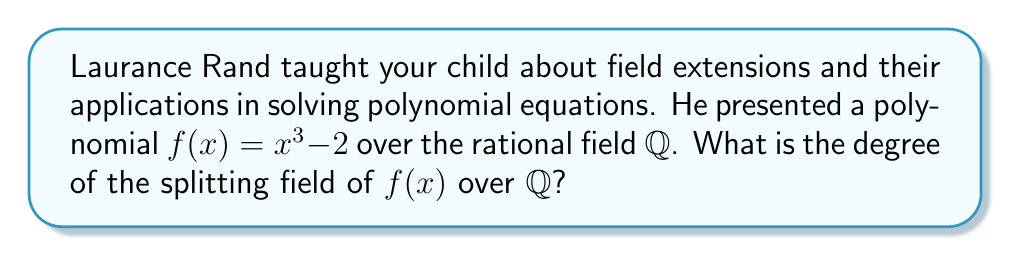Provide a solution to this math problem. Let's approach this step-by-step:

1) First, we need to find the roots of $f(x) = x^3 - 2$. 
   One real root is $\sqrt[3]{2}$. The other two roots are complex.

2) Let $\omega = e^{2\pi i/3} = -\frac{1}{2} + i\frac{\sqrt{3}}{2}$ be a primitive cube root of unity.
   Then the roots of $f(x)$ are:
   $$\sqrt[3]{2}, \omega\sqrt[3]{2}, \omega^2\sqrt[3]{2}$$

3) The splitting field of $f(x)$ over $\mathbb{Q}$ is:
   $$\mathbb{Q}(\sqrt[3]{2}, \omega)$$

4) To find the degree of this extension, we can use the tower law:
   $$[\mathbb{Q}(\sqrt[3]{2}, \omega) : \mathbb{Q}] = [\mathbb{Q}(\sqrt[3]{2}, \omega) : \mathbb{Q}(\sqrt[3]{2})][\mathbb{Q}(\sqrt[3]{2}) : \mathbb{Q}]$$

5) $[\mathbb{Q}(\sqrt[3]{2}) : \mathbb{Q}] = 3$ because $x^3 - 2$ is irreducible over $\mathbb{Q}$.

6) $[\mathbb{Q}(\sqrt[3]{2}, \omega) : \mathbb{Q}(\sqrt[3]{2})] = 2$ because $\omega$ satisfies $x^2 + x + 1 = 0$ over $\mathbb{Q}(\sqrt[3]{2})$.

7) Therefore, the degree of the splitting field is:
   $$[\mathbb{Q}(\sqrt[3]{2}, \omega) : \mathbb{Q}] = 2 \cdot 3 = 6$$
Answer: 6 